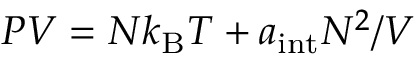<formula> <loc_0><loc_0><loc_500><loc_500>P V = N k _ { B } T + a _ { i n t } N ^ { 2 } / V</formula> 